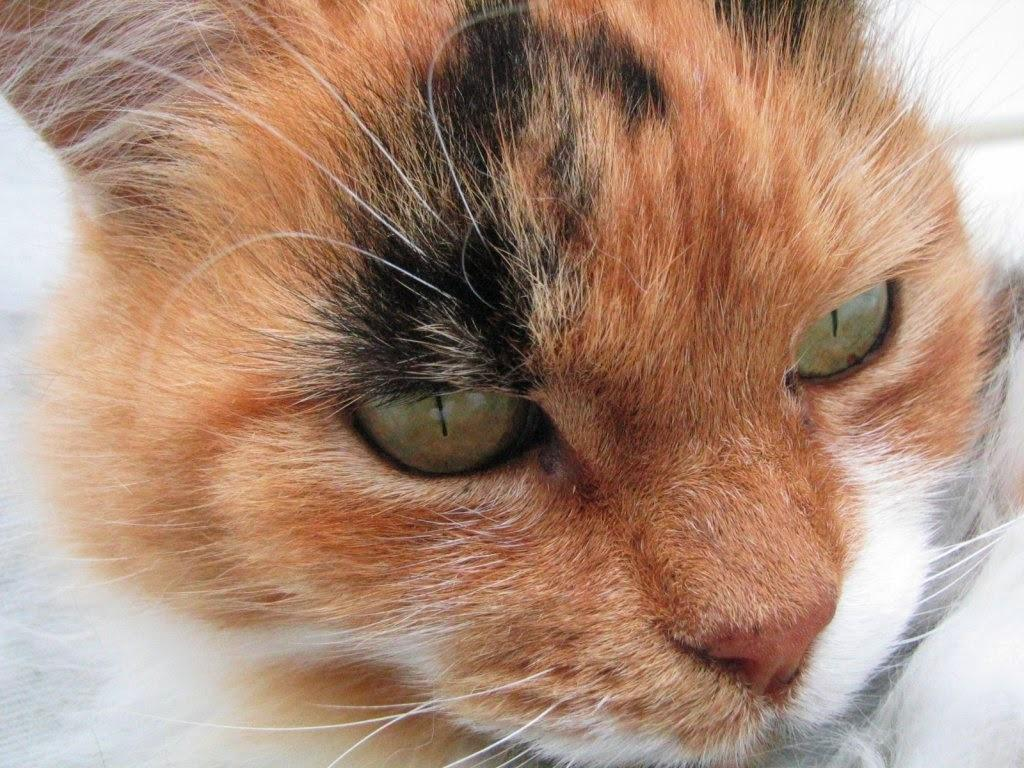What is the main subject of the image? The main subject of the image is a cat's face. Can you describe the colors of the cat's face in the image? The cat's face is in brown and white colors. What type of rhythm can be heard coming from the owl in the image? There is no owl present in the image, so it's not possible to determine what, if any, rhythm might be heard. 